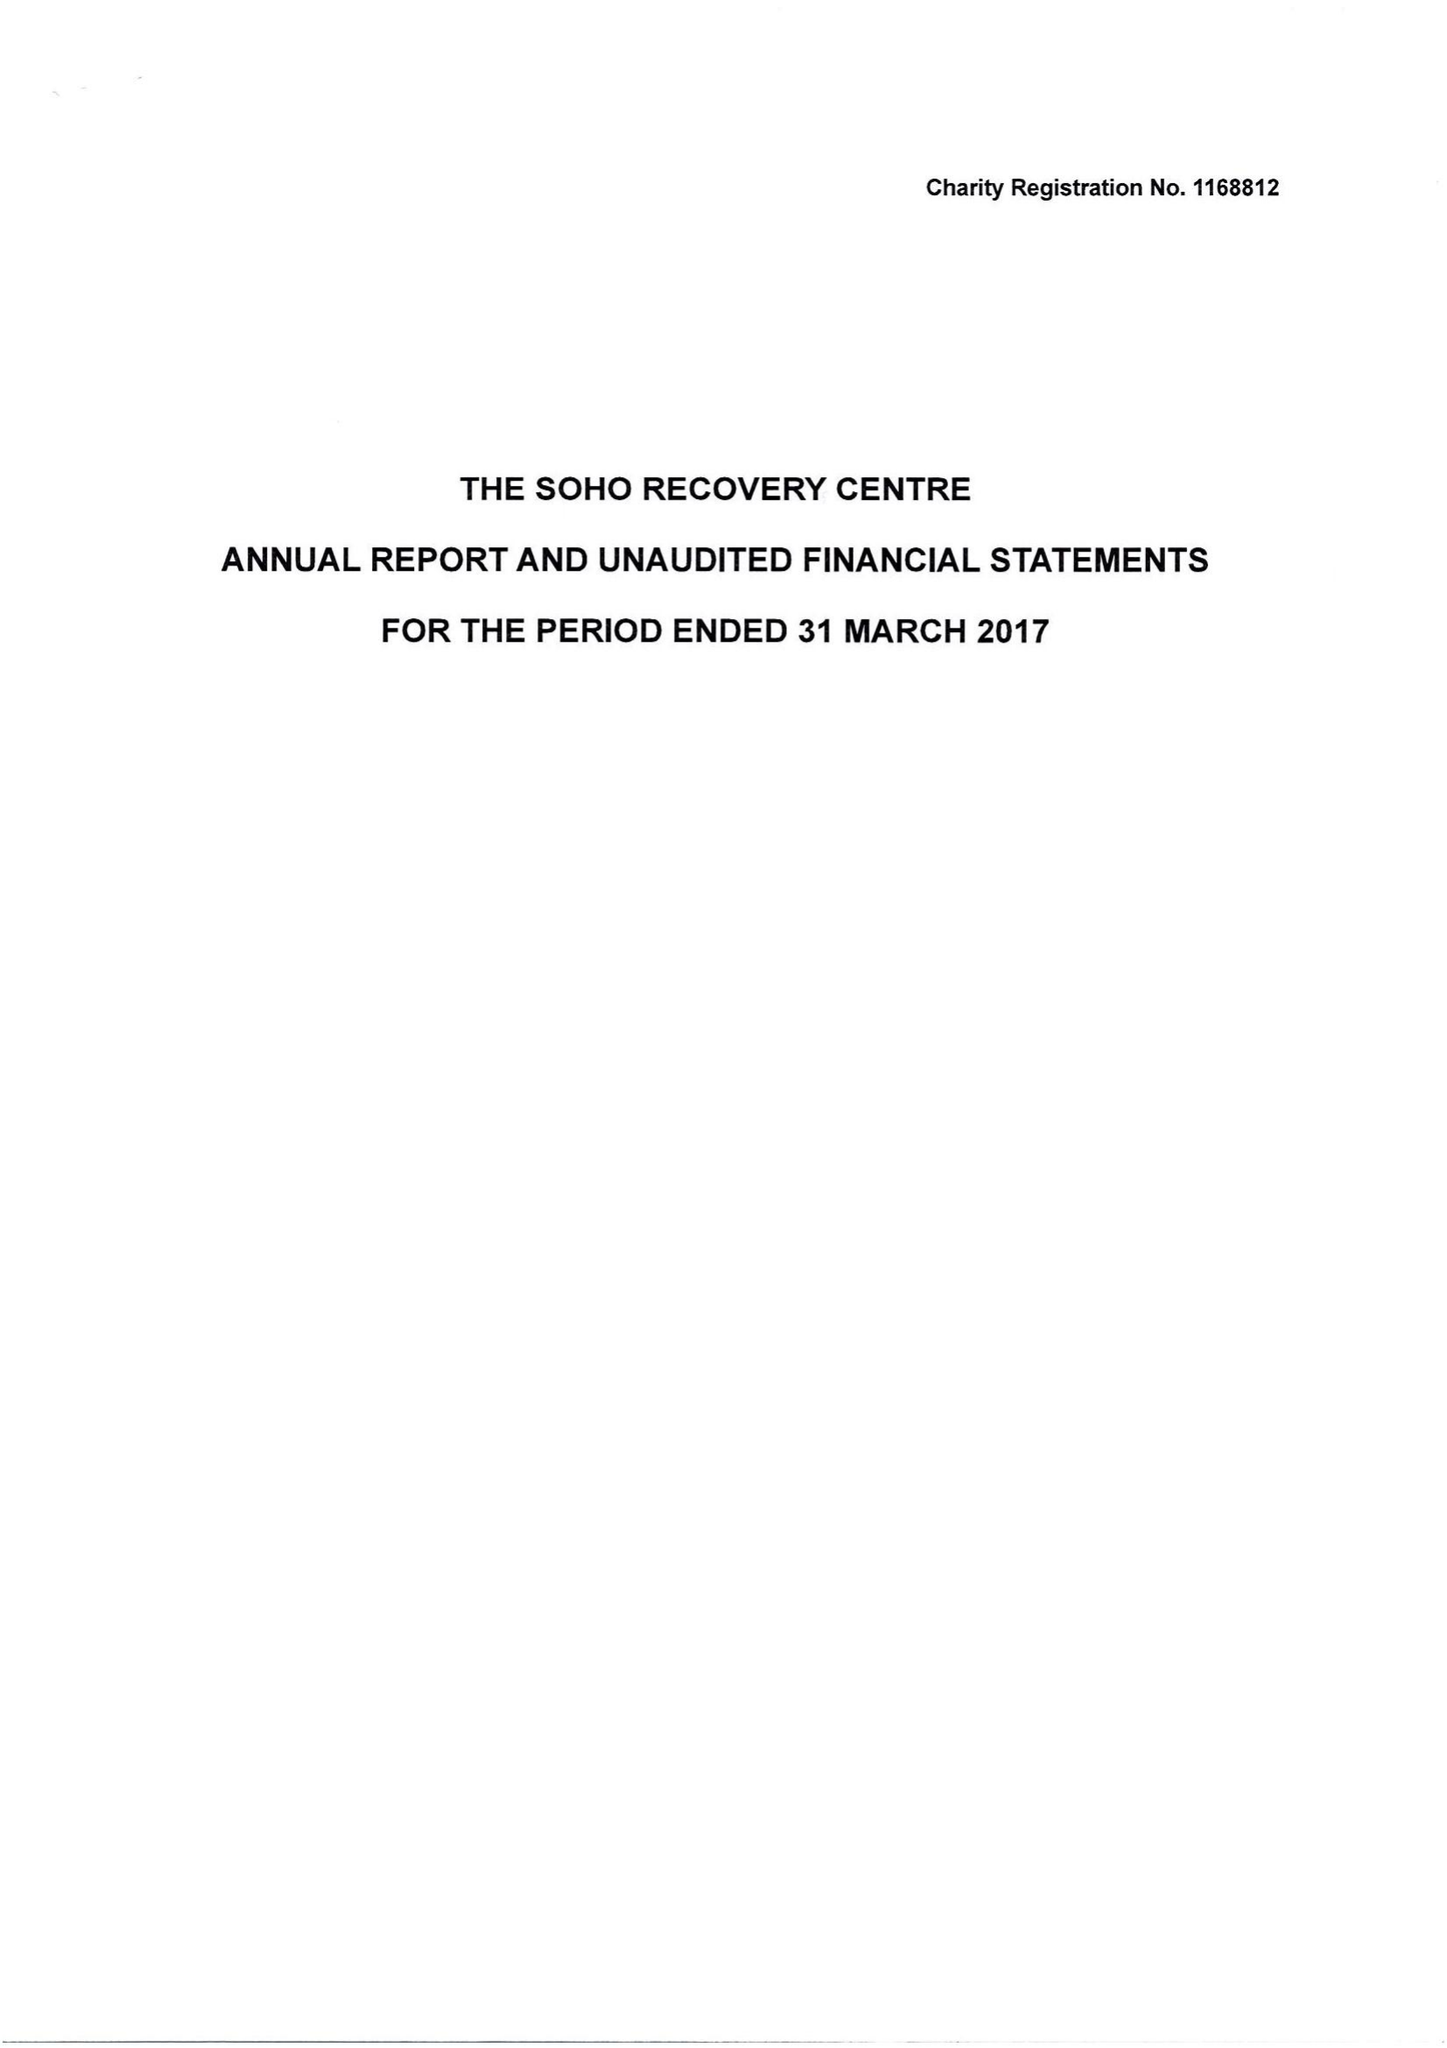What is the value for the address__postcode?
Answer the question using a single word or phrase. WC2H 0EW 